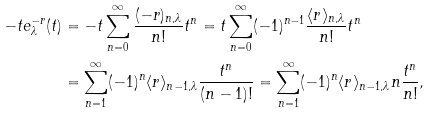Convert formula to latex. <formula><loc_0><loc_0><loc_500><loc_500>- t e _ { \lambda } ^ { - r } ( t ) & = - t \sum _ { n = 0 } ^ { \infty } \frac { ( - r ) _ { n , \lambda } } { n ! } t ^ { n } = t \sum _ { n = 0 } ^ { \infty } ( - 1 ) ^ { n - 1 } \frac { \langle r \rangle _ { n , \lambda } } { n ! } t ^ { n } \\ & = \sum _ { n = 1 } ^ { \infty } ( - 1 ) ^ { n } \langle r \rangle _ { n - 1 , \lambda } \frac { t ^ { n } } { ( n - 1 ) ! } = \sum _ { n = 1 } ^ { \infty } ( - 1 ) ^ { n } \langle r \rangle _ { n - 1 , \lambda } n \frac { t ^ { n } } { n ! } ,</formula> 